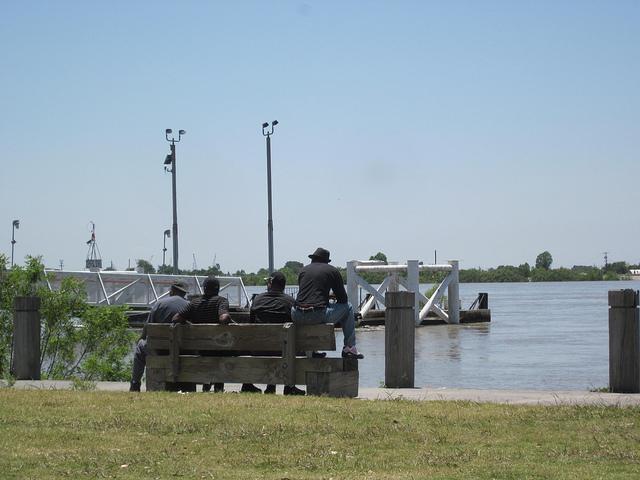Who is sitting on the bench?
Short answer required. People. Is this a dock?
Write a very short answer. Yes. What are they looking at?
Concise answer only. Water. Where is the bench?
Keep it brief. By water. What is the weather like on this day?
Keep it brief. Sunny. How many men are seated?
Be succinct. 4. What is on the bench?
Give a very brief answer. People. How many people are sitting on the benches?
Keep it brief. 4. Are the benches on grass?
Short answer required. Yes. What color is the object at the end of the concrete pier?
Concise answer only. Black. What type of liquid are the men facing?
Concise answer only. Water. Is the sky clear?
Quick response, please. Yes. Is it a cloudy day?
Write a very short answer. No. What is on the person's head?
Write a very short answer. Hat. What is in the grass?
Quick response, please. Bench. Why are those poles in the picture?
Answer briefly. Lights. What are the boys talking about?
Keep it brief. Girls. 